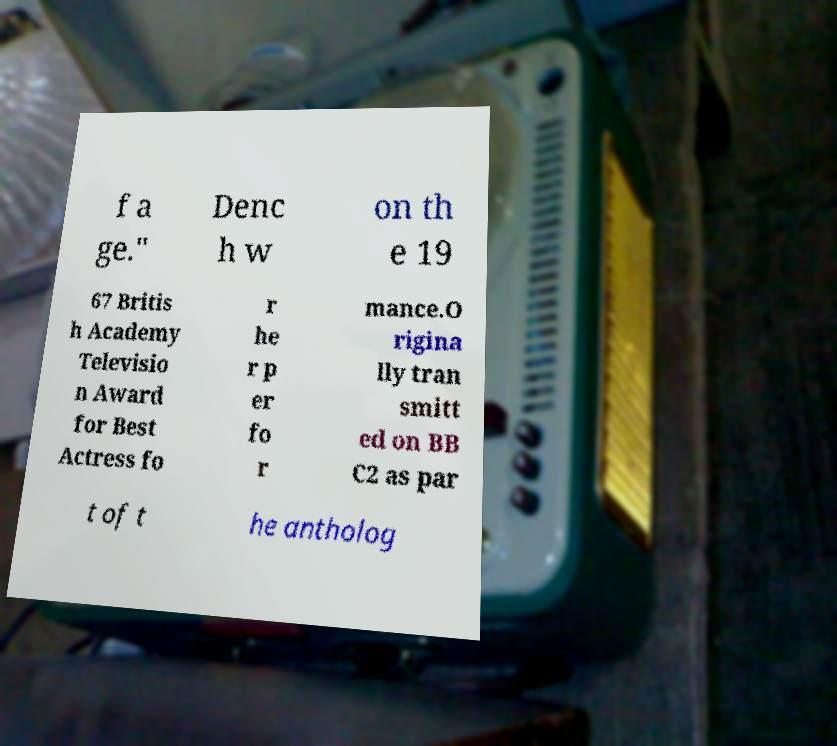I need the written content from this picture converted into text. Can you do that? f a ge." Denc h w on th e 19 67 Britis h Academy Televisio n Award for Best Actress fo r he r p er fo r mance.O rigina lly tran smitt ed on BB C2 as par t of t he antholog 